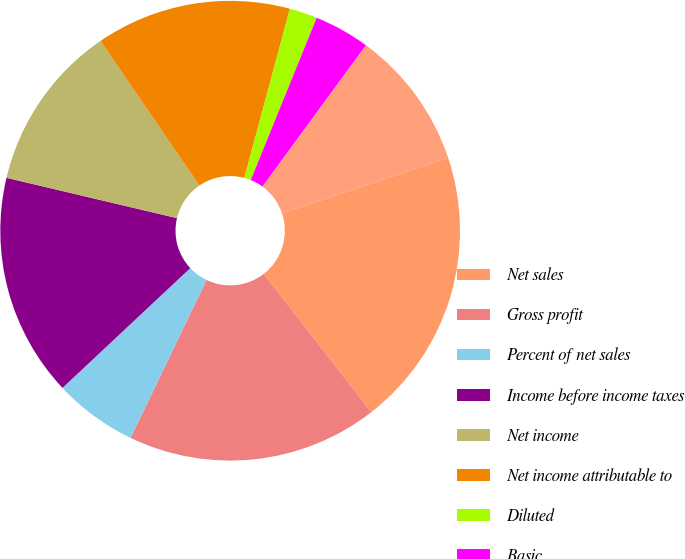Convert chart to OTSL. <chart><loc_0><loc_0><loc_500><loc_500><pie_chart><fcel>Net sales<fcel>Gross profit<fcel>Percent of net sales<fcel>Income before income taxes<fcel>Net income<fcel>Net income attributable to<fcel>Diluted<fcel>Basic<fcel>Cash dividends declared per<fcel>High<nl><fcel>19.61%<fcel>17.65%<fcel>5.88%<fcel>15.68%<fcel>11.76%<fcel>13.72%<fcel>1.96%<fcel>3.92%<fcel>0.0%<fcel>9.8%<nl></chart> 